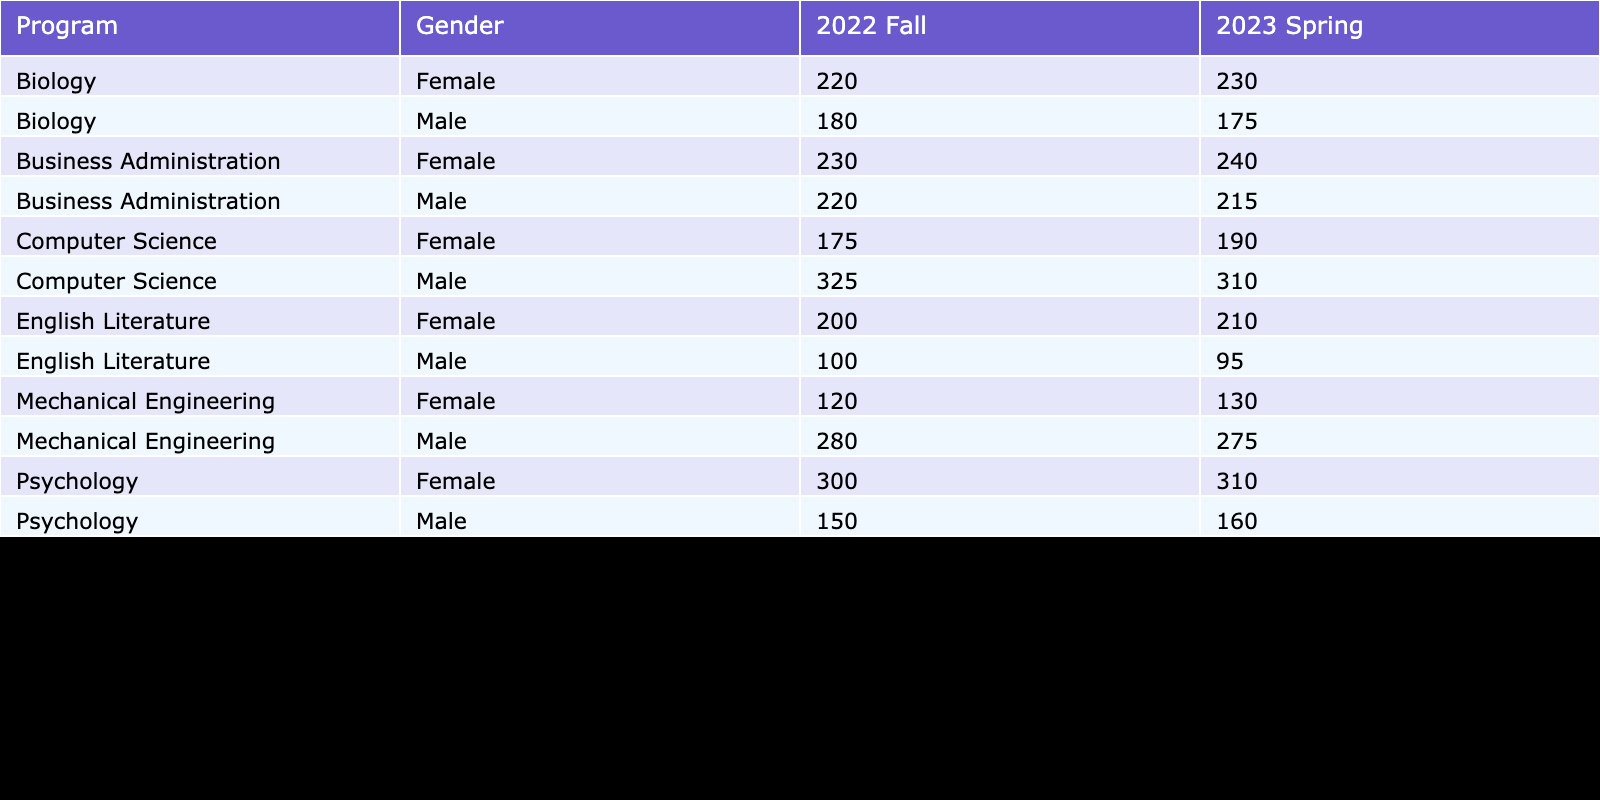What is the total enrollment count for Computer Science in Fall 2022? From the table, the enrollment count for Computer Science in Fall 2022 is split between males and females: 325 males and 175 females. To find the total, we sum these values: 325 + 175 = 500.
Answer: 500 Which program had the highest female enrollment in Spring 2023? Looking at the Spring 2023 row, the enrollment counts for females are: Computer Science 190, Mechanical Engineering 130, Business Administration 240, Psychology 310, Biology 230, and English Literature 210. Among these, Psychology has the highest female enrollment with 310.
Answer: Psychology Is the average GPA for male students in Business Administration higher than that in Mechanical Engineering? The average GPA for male students in Business Administration is 3.2, while in Mechanical Engineering it is 3.2 as well. Since both values are equal, the statement is false as they are not higher in one program compared to the other.
Answer: No What is the percentage difference in enrollment count between male and female students in Psychology for Fall 2022? In Psychology for Fall 2022, the male enrollment count is 150 and the female count is 300. The difference is 300 - 150 = 150. To find the percentage difference relative to male enrollment, we calculate (150/150) * 100, which equals 100%.
Answer: 100% What is the total enrollment count for each gender across all programs in Spring 2023? To find this, we sum the enrollment counts for males and females from the Spring 2023 rows in the table. The totals are: Males: 310 (CS) + 275 (ME) + 215 (BA) + 160 (PSY) + 175 (BIO) + 95 (EL) = 1230; Females: 190 (CS) + 130 (ME) + 240 (BA) + 310 (PSY) + 230 (BIO) + 210 (EL) = 1310.
Answer: Males: 1230, Females: 1310 